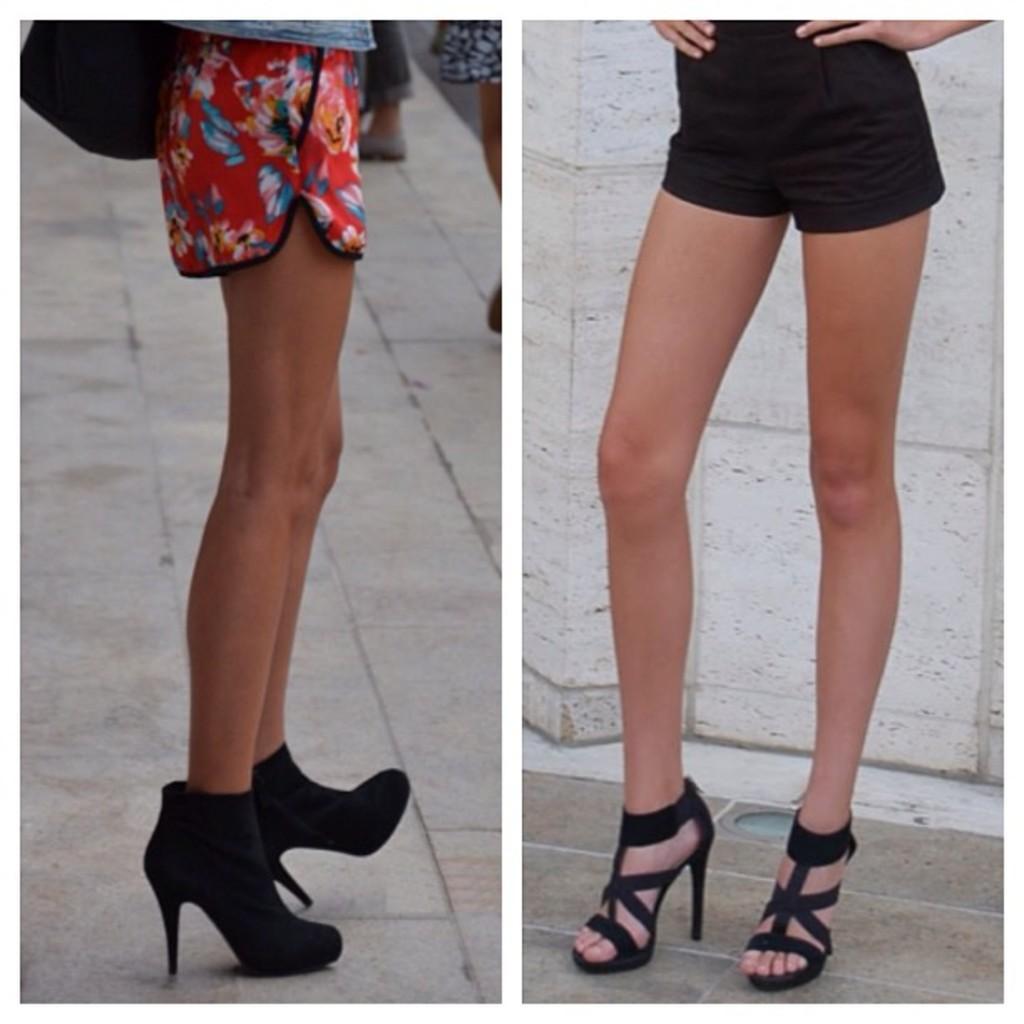Please provide a concise description of this image. This is a collage picture. In this picture we can see the legs of the people wearing footwear. We can see the wall and the floor. 